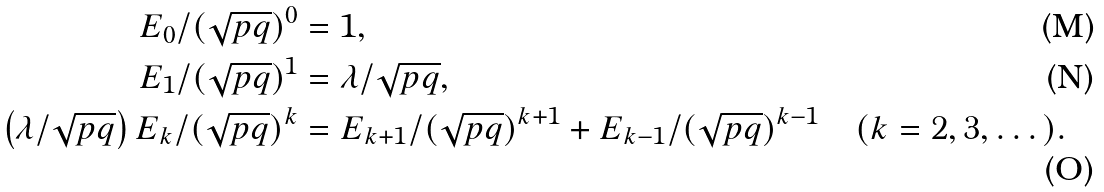<formula> <loc_0><loc_0><loc_500><loc_500>E _ { 0 } / ( \sqrt { p q } ) ^ { 0 } & = 1 , \\ E _ { 1 } / ( \sqrt { p q } ) ^ { 1 } & = \lambda / \sqrt { p q } , \\ \left ( \lambda / \sqrt { p q } \right ) E _ { k } / ( \sqrt { p q } ) ^ { k } & = E _ { k + 1 } / ( \sqrt { p q } ) ^ { k + 1 } + E _ { k - 1 } / ( \sqrt { p q } ) ^ { k - 1 } \quad ( k = 2 , 3 , \dots ) .</formula> 